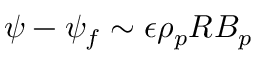Convert formula to latex. <formula><loc_0><loc_0><loc_500><loc_500>\psi - \psi _ { f } \sim \epsilon \rho _ { p } R B _ { p }</formula> 